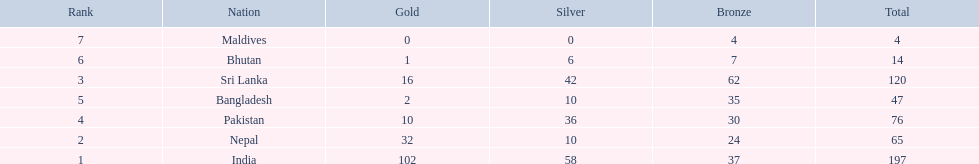Which nations played at the 1999 south asian games? India, Nepal, Sri Lanka, Pakistan, Bangladesh, Bhutan, Maldives. Which country is listed second in the table? Nepal. 